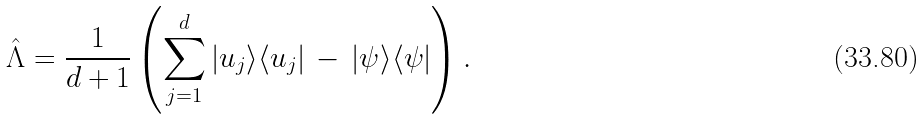Convert formula to latex. <formula><loc_0><loc_0><loc_500><loc_500>\hat { \Lambda } = \frac { 1 } { d + 1 } \left ( \sum _ { j = 1 } ^ { d } | u _ { j } \rangle \langle u _ { j } | \, - \, | \psi \rangle \langle \psi | \right ) .</formula> 